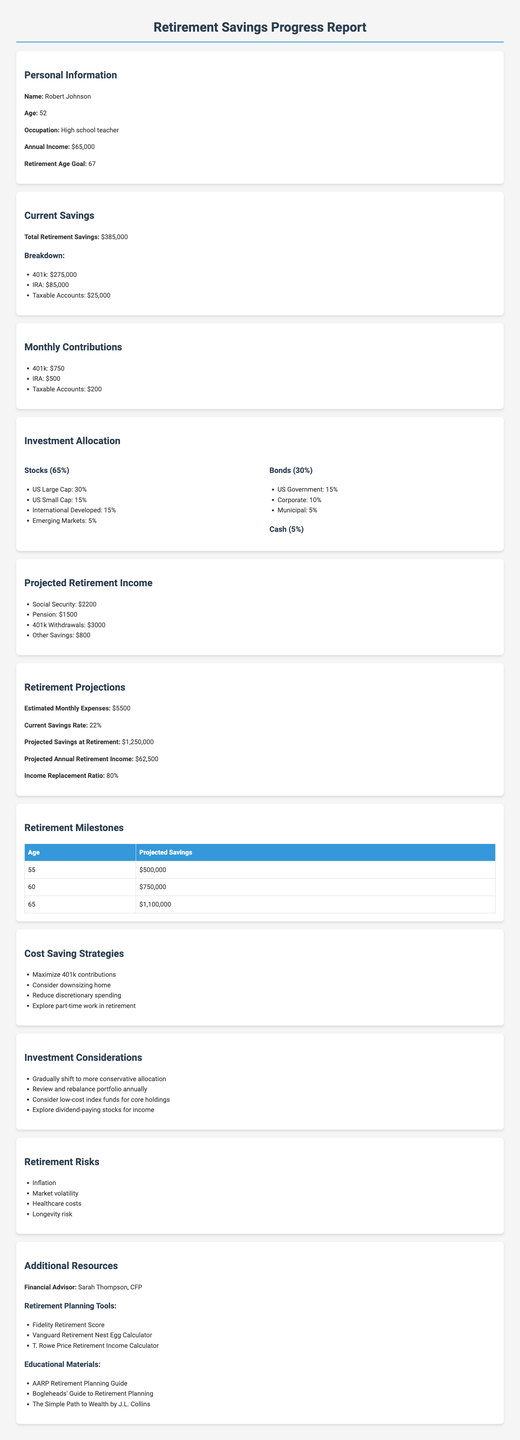what is the total retirement savings? The total retirement savings is clearly stated in the document as $385000.
Answer: $385000 what is the age at which Robert wishes to retire? The document specifies Robert's retirement age goal, which is 67 years old.
Answer: 67 how much is the monthly contribution to the IRA? The document provides the monthly contribution to the IRA, which is $500.
Answer: $500 what is the projected savings at age 60? The document lists the projected savings at age 60, which is $750000.
Answer: $750000 what percentage of investments is allocated to bonds? The investment allocation section shows that 30% of investments are in bonds.
Answer: 30% what strategy is recommended for reducing discretionary spending? The document suggests reducing discretionary spending as a cost-saving strategy.
Answer: Reduce discretionary spending what is Robert's projected annual retirement income? The document states that the projected annual retirement income is $62500.
Answer: $62500 what is one recommended investment consideration? The document lists several investment considerations, one of which is to consider low-cost index funds for core holdings.
Answer: Consider low-cost index funds for core holdings what is the income replacement ratio at retirement? The document indicates the income replacement ratio is 80%.
Answer: 80% 